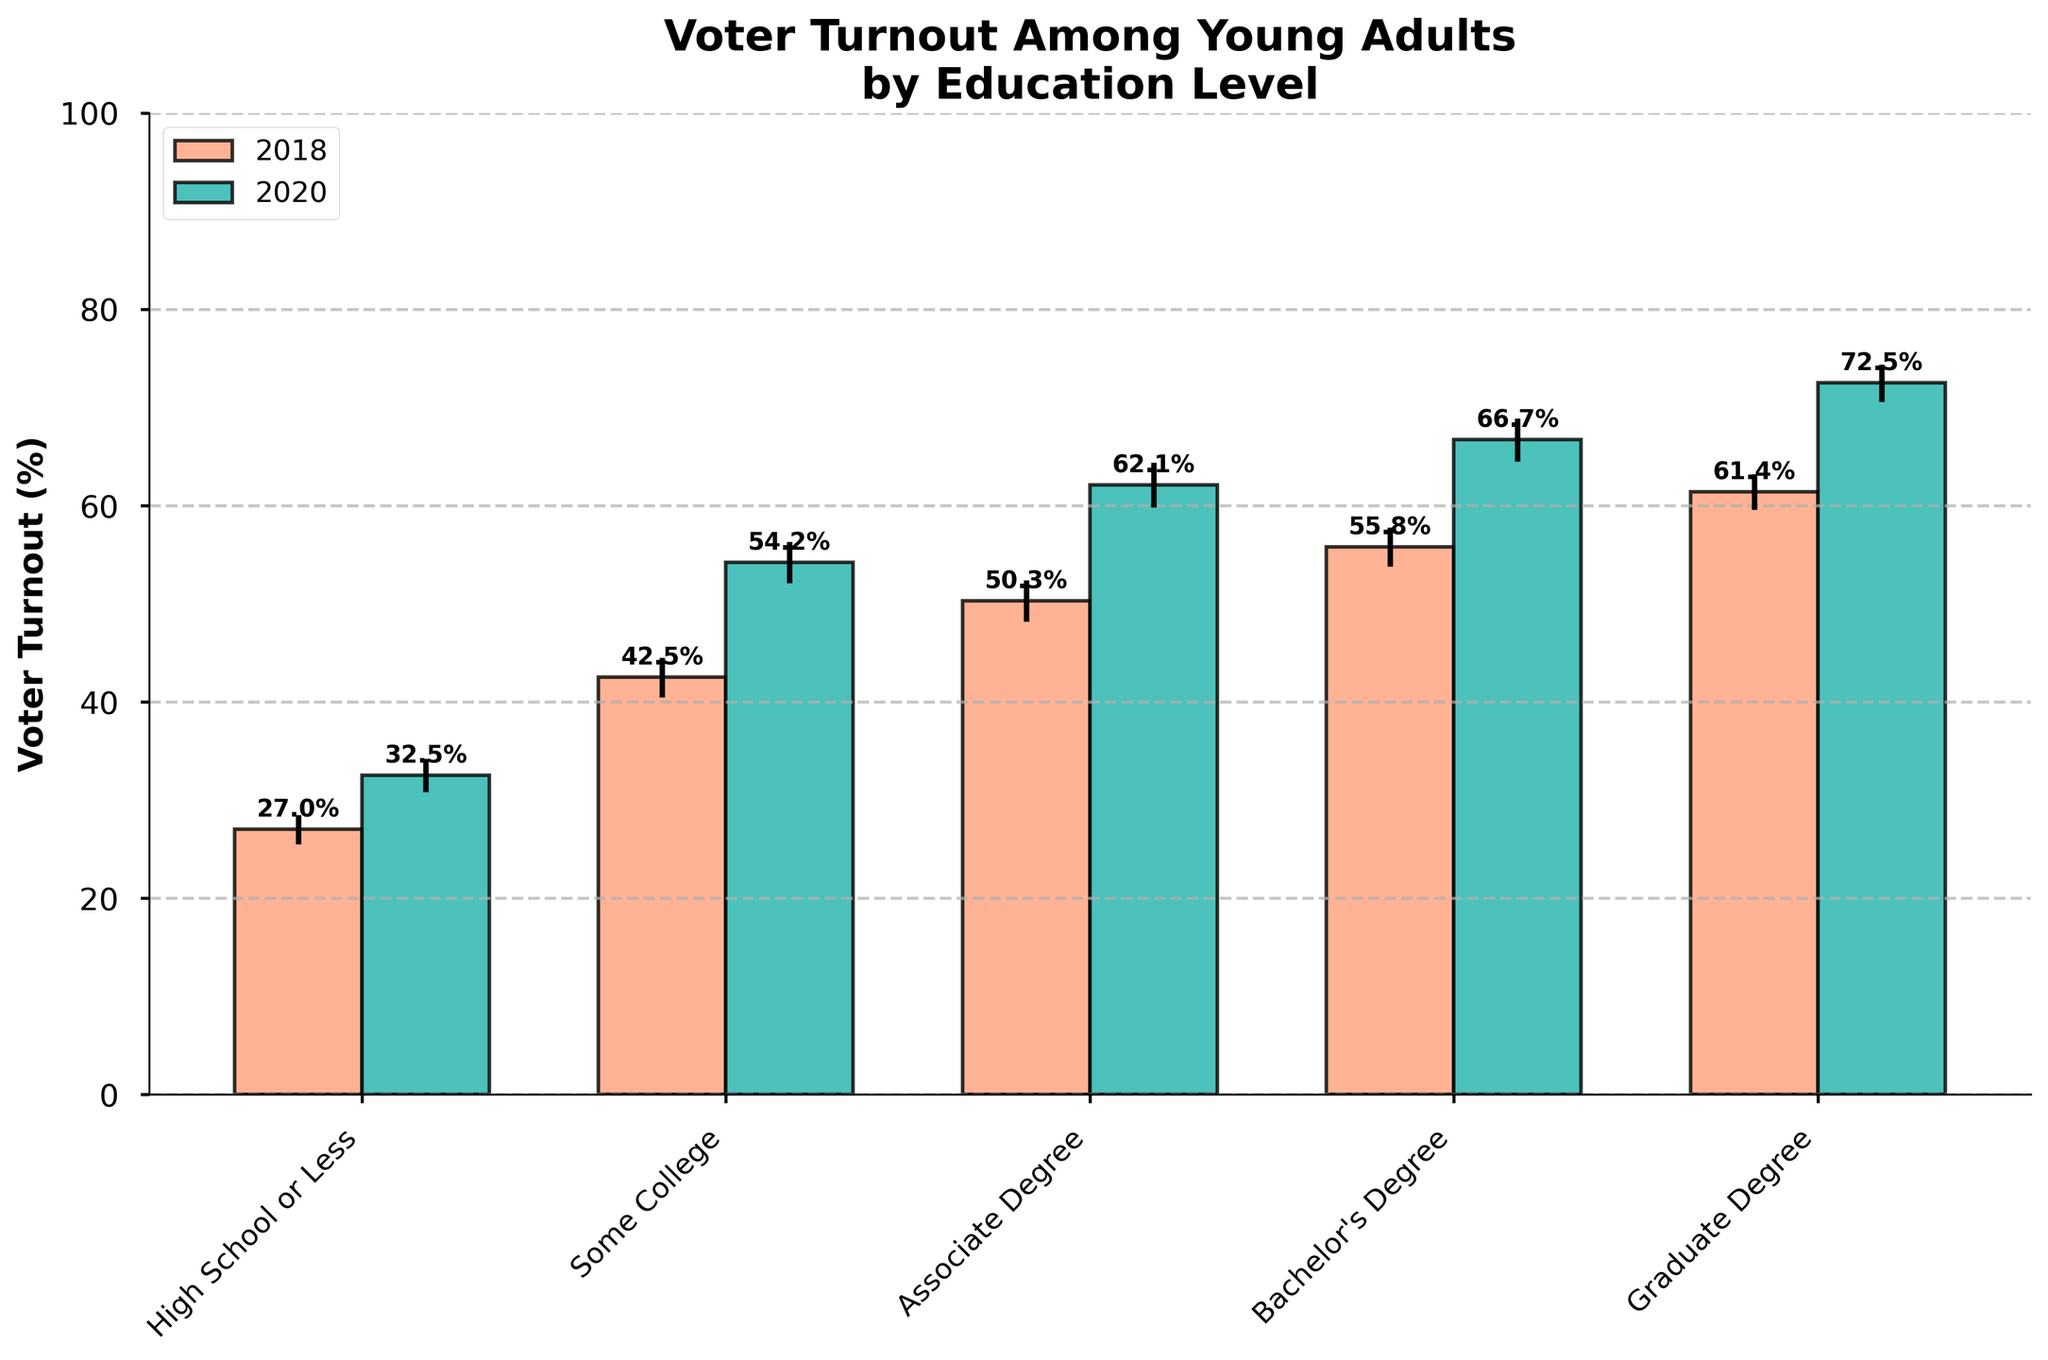What's the title of the figure? The title is displayed at the top of the figure, summarizing what the figure is about. It usually provides an overview of the visualized data.
Answer: Voter Turnout Among Young Adults by Education Level What is the y-axis label? The y-axis label is found along the vertical axis of the bar chart and indicates what the bars' heights represent.
Answer: Voter Turnout (%) Which education level had the highest voter turnout in 2020? Look at the tallest bar representing 2020 in the bar chart to see which category it corresponds to.
Answer: Graduate Degree Which education level saw the greatest increase in voter turnout from 2018 to 2020? Subtract the 2018 turnout percentages from the 2020 turnout percentages for all education levels and see which is the highest. High School or Less: 32.5 - 27.0 = 5.5%, Some College: 54.2 - 42.5 = 11.7%, Associate Degree: 62.1 - 50.3 = 11.8%, Bachelor's Degree: 66.7 - 55.8 = 10.9%, Graduate Degree: 72.5 - 61.4 = 11.1%
Answer: Associate Degree What is the voter turnout in 2018 for those with a Bachelor's Degree? Locate the bar for a Bachelor's Degree in 2018 and read its height percentage.
Answer: 55.8% What is the margin of error for the 2020 voter turnout among young adults with an Associate Degree? Find the error bar's value associated with the 2020 bar for Associate Degree.
Answer: 2.3% How much more was the 2020 voter turnout than the 2018 voter turnout for those with a Graduate Degree? Subtract the 2018 voter turnout (%) from the 2020 voter turnout (%) for a Graduate Degree.
Answer: 72.5% - 61.4% = 11.1% Which education level has the smallest margin of error in 2020? Compare all the error bar values for 2020 and find the smallest one.
Answer: Graduate Degree Which year had a higher overall voter turnout across all education levels? Compare the height of the bars across both years for each education level and observe the trends.
Answer: 2020 Are the error bars larger or smaller in 2020 compared to 2018 for the Bachelor's Degree group? Compare the length of the error bars for the Bachelor's Degree group between 2020 and 2018.
Answer: Larger in 2020 